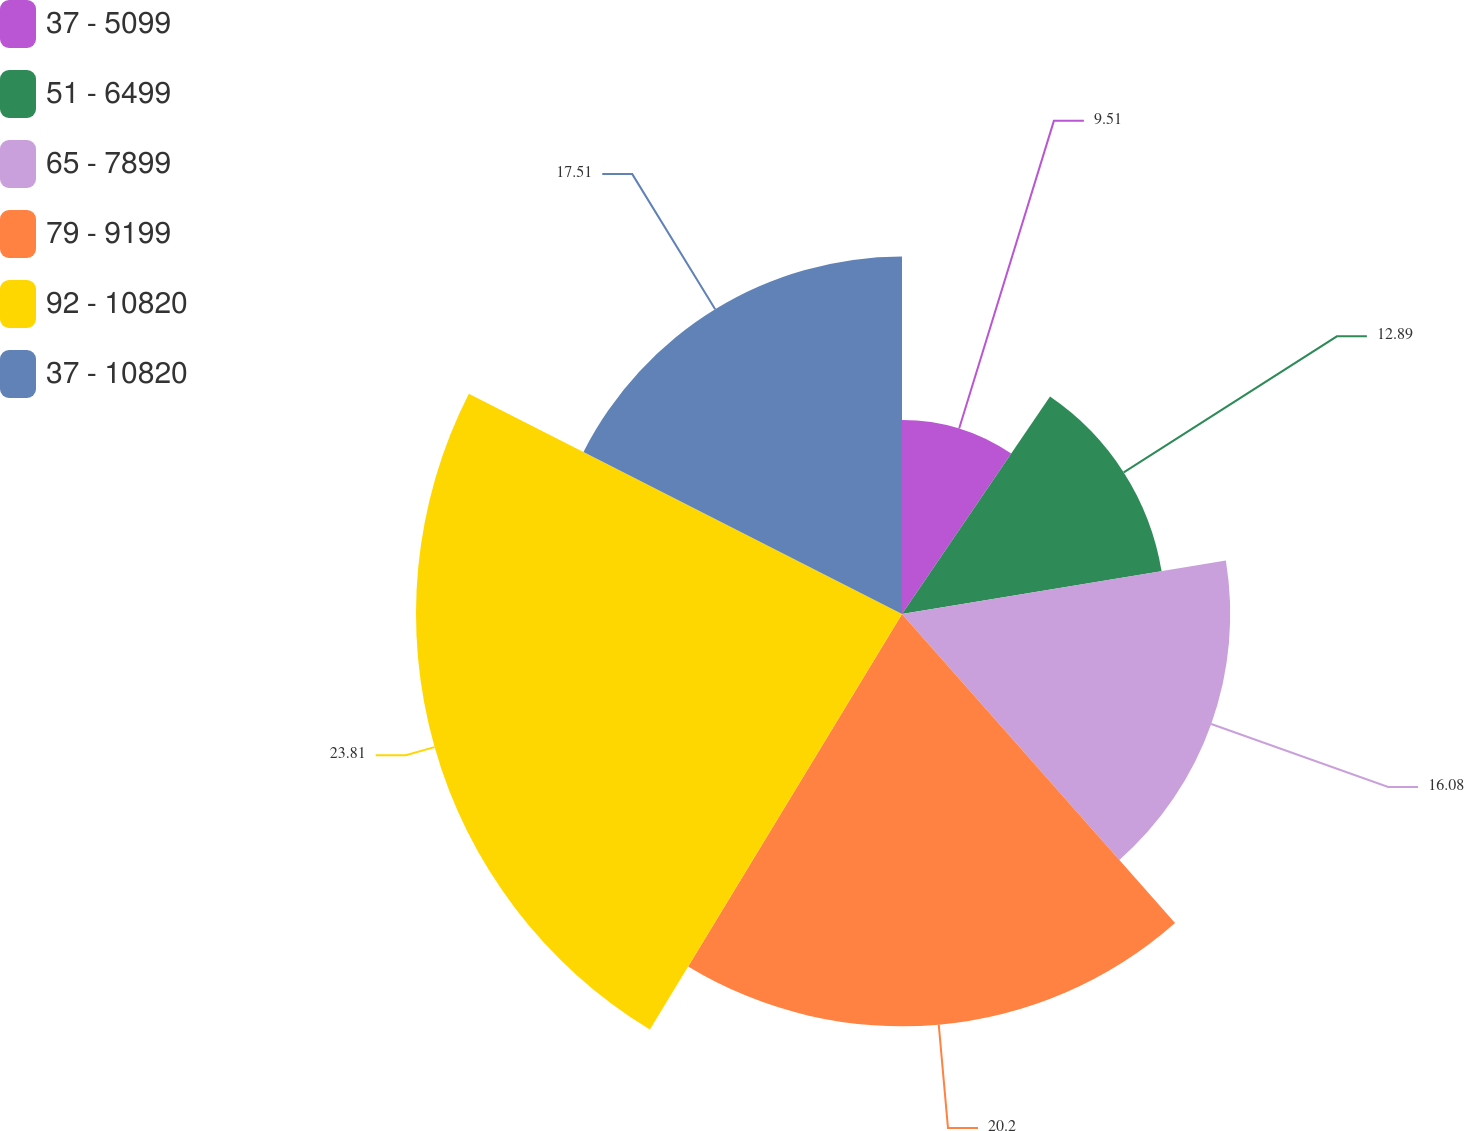<chart> <loc_0><loc_0><loc_500><loc_500><pie_chart><fcel>37 - 5099<fcel>51 - 6499<fcel>65 - 7899<fcel>79 - 9199<fcel>92 - 10820<fcel>37 - 10820<nl><fcel>9.51%<fcel>12.89%<fcel>16.08%<fcel>20.2%<fcel>23.81%<fcel>17.51%<nl></chart> 